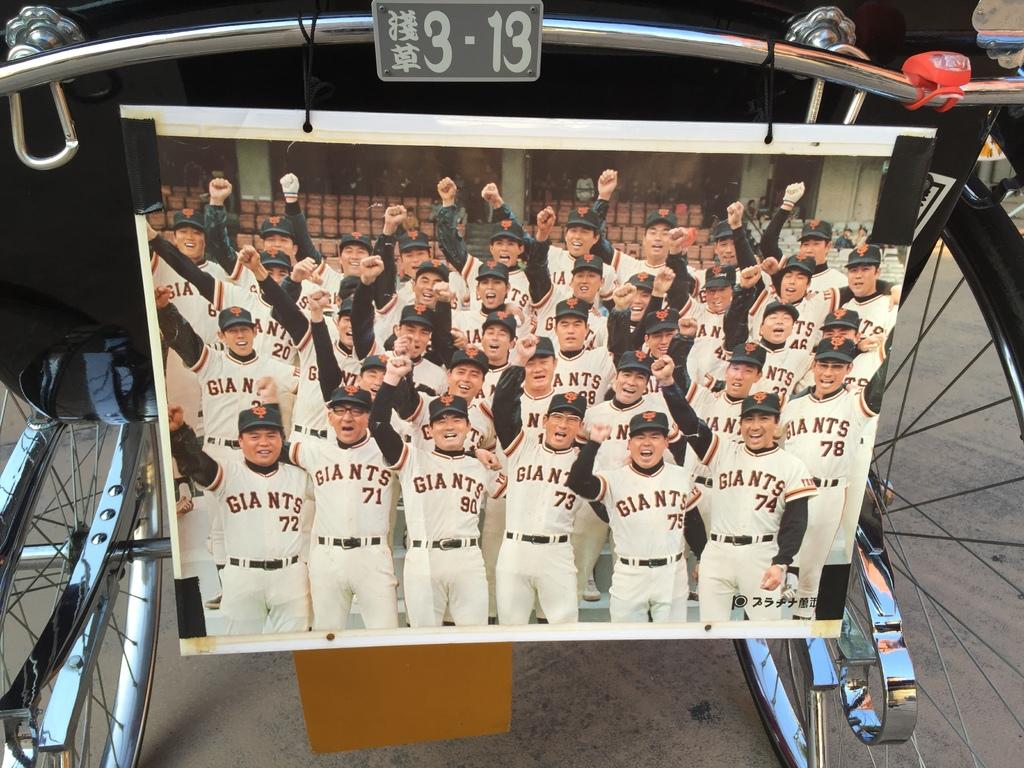What team do the players represent?
Your answer should be very brief. Giants. 